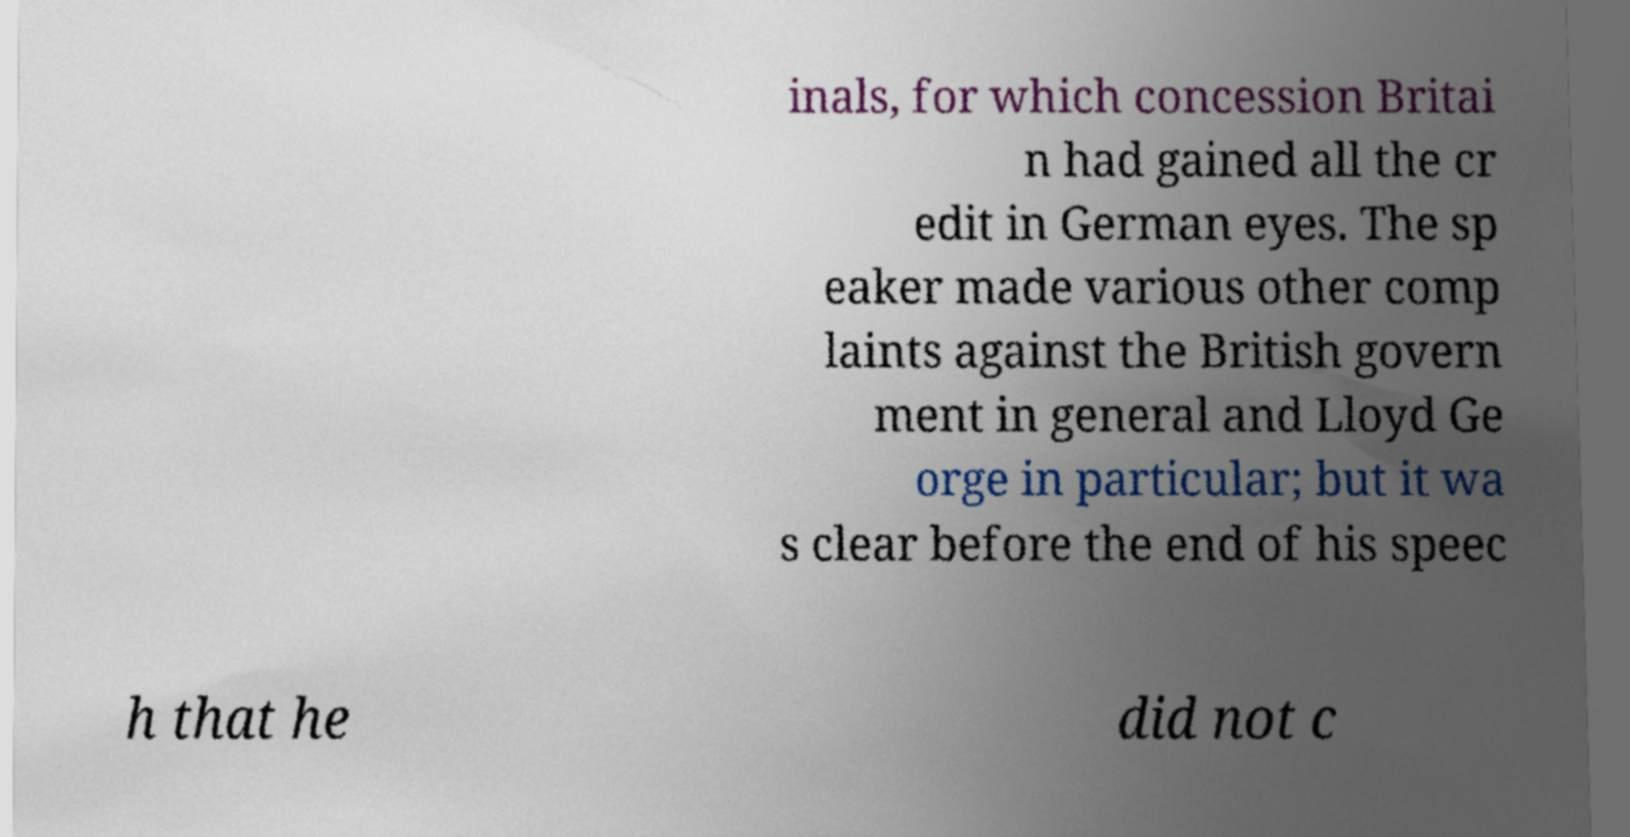Please identify and transcribe the text found in this image. inals, for which concession Britai n had gained all the cr edit in German eyes. The sp eaker made various other comp laints against the British govern ment in general and Lloyd Ge orge in particular; but it wa s clear before the end of his speec h that he did not c 